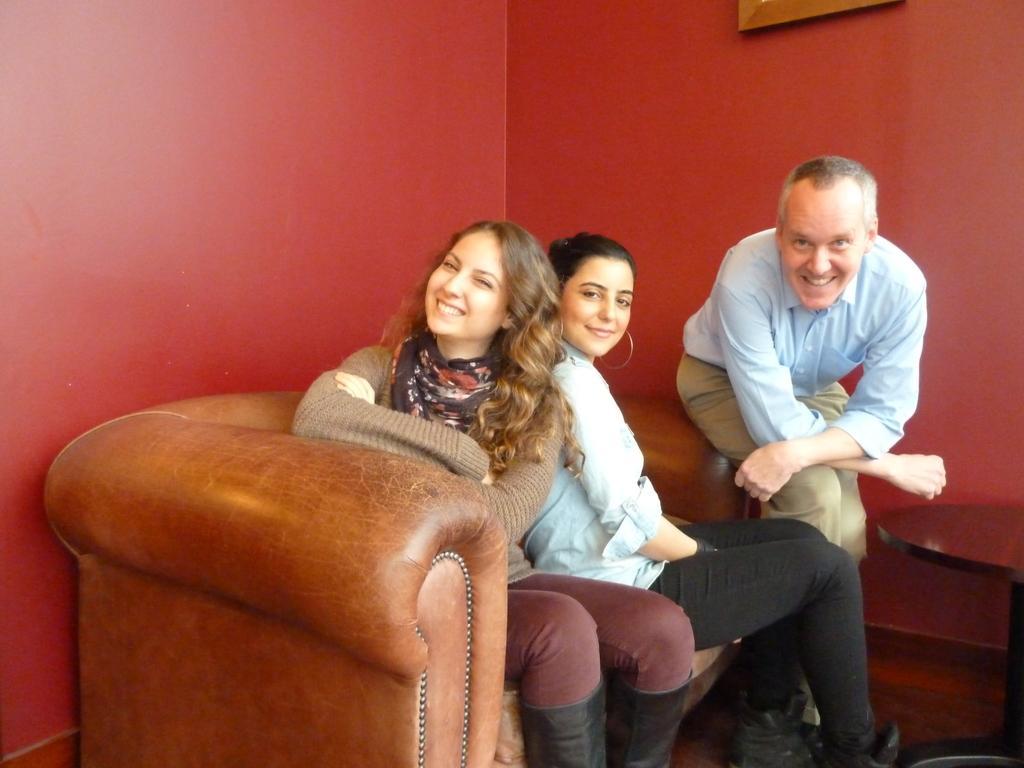Please provide a concise description of this image. In this image we can see two women are smiling and sitting on the sofa and this person wearing is also sitting and smiling. Here we can see a table and we can see your photo frame on the maroon color wall. 